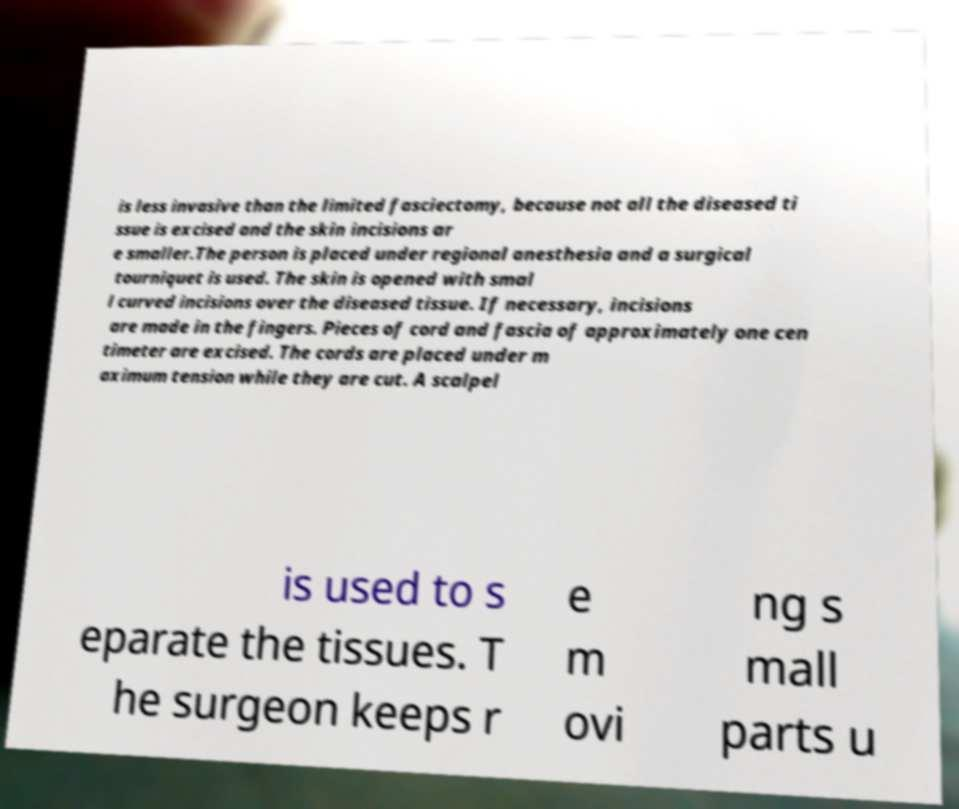Could you extract and type out the text from this image? is less invasive than the limited fasciectomy, because not all the diseased ti ssue is excised and the skin incisions ar e smaller.The person is placed under regional anesthesia and a surgical tourniquet is used. The skin is opened with smal l curved incisions over the diseased tissue. If necessary, incisions are made in the fingers. Pieces of cord and fascia of approximately one cen timeter are excised. The cords are placed under m aximum tension while they are cut. A scalpel is used to s eparate the tissues. T he surgeon keeps r e m ovi ng s mall parts u 